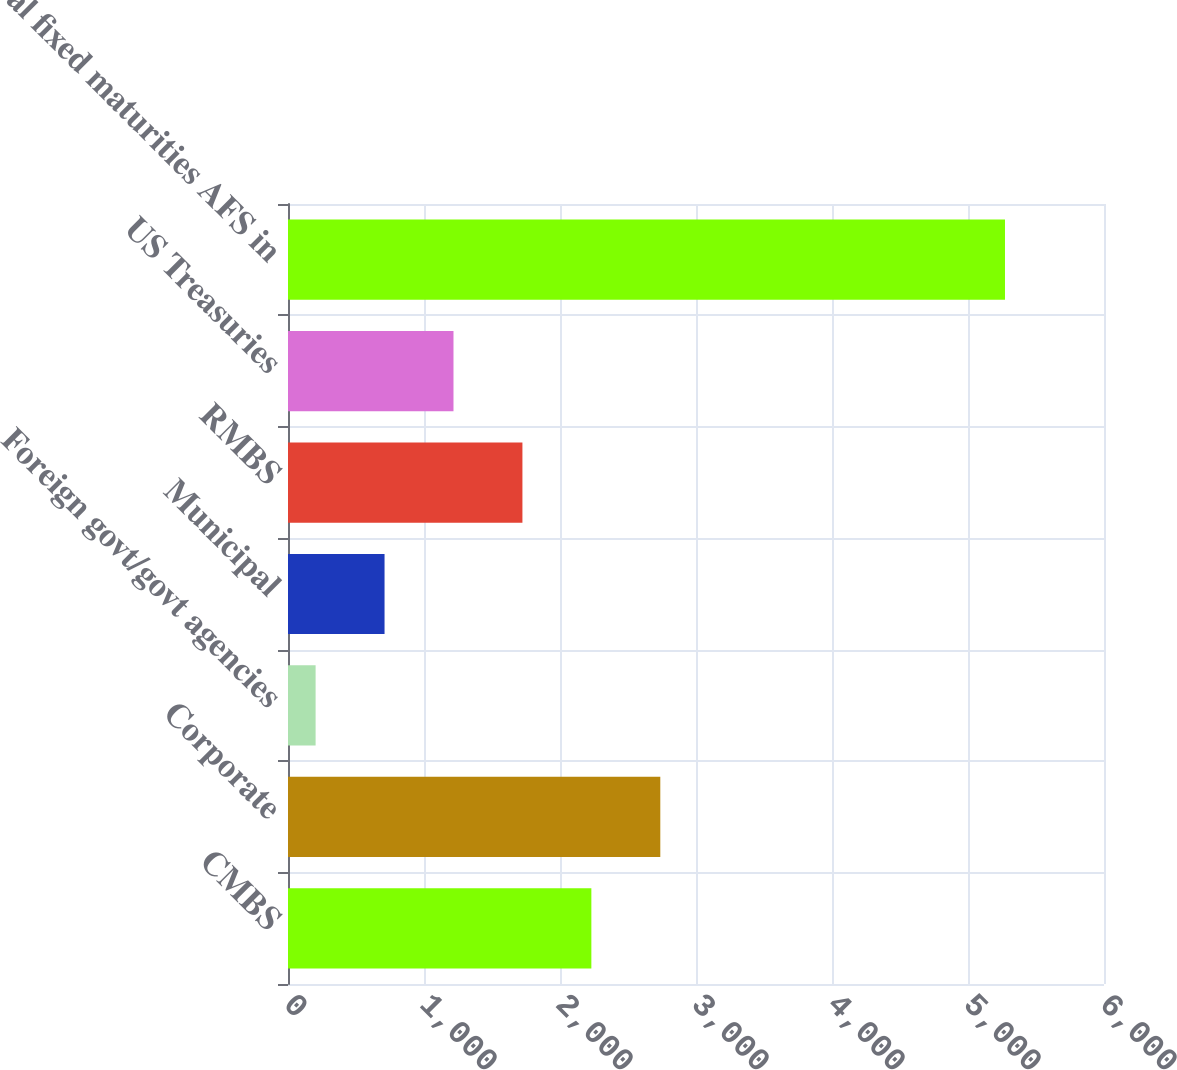Convert chart. <chart><loc_0><loc_0><loc_500><loc_500><bar_chart><fcel>CMBS<fcel>Corporate<fcel>Foreign govt/govt agencies<fcel>Municipal<fcel>RMBS<fcel>US Treasuries<fcel>Total fixed maturities AFS in<nl><fcel>2230.6<fcel>2737.5<fcel>203<fcel>709.9<fcel>1723.7<fcel>1216.8<fcel>5272<nl></chart> 